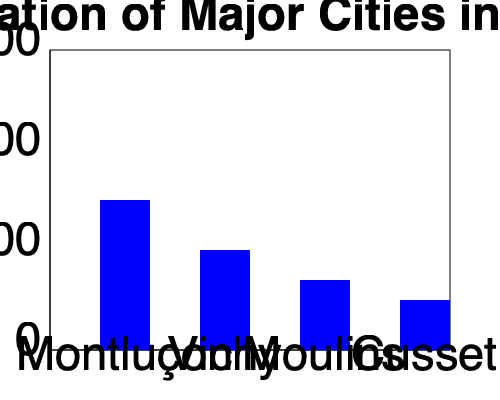Analyzing the bar graph of population distribution in Allier's major cities, what percentage of the total population of these four cities does Montluçon represent, and what political implications might this have for local governance? To answer this question, we need to follow these steps:

1. Calculate the total population of the four cities:
   Montluçon: 35,000
   Vichy: 25,000
   Moulins: 17,500
   Cusset: 12,500
   Total: 35,000 + 25,000 + 17,500 + 12,500 = 90,000

2. Calculate the percentage of Montluçon's population:
   (35,000 / 90,000) * 100 = 38.89%

3. Round to the nearest whole number: 39%

Political implications:
1. Representation: Montluçon, having the largest population, may have more representatives in local government bodies.
2. Resource allocation: A larger share of the department's budget might be allocated to Montluçon for infrastructure and services.
3. Political influence: Politicians from Montluçon may have more influence in departmental decision-making processes.
4. Electoral significance: Candidates may focus more on Montluçon during local elections due to its large voter base.
5. Policy priorities: Issues affecting Montluçon may receive more attention in local politics.
6. Inter-city dynamics: There could be tension between Montluçon and smaller cities over resource distribution and political power.
Answer: 39%; increased representation, resource allocation, and political influence for Montluçon in local governance. 